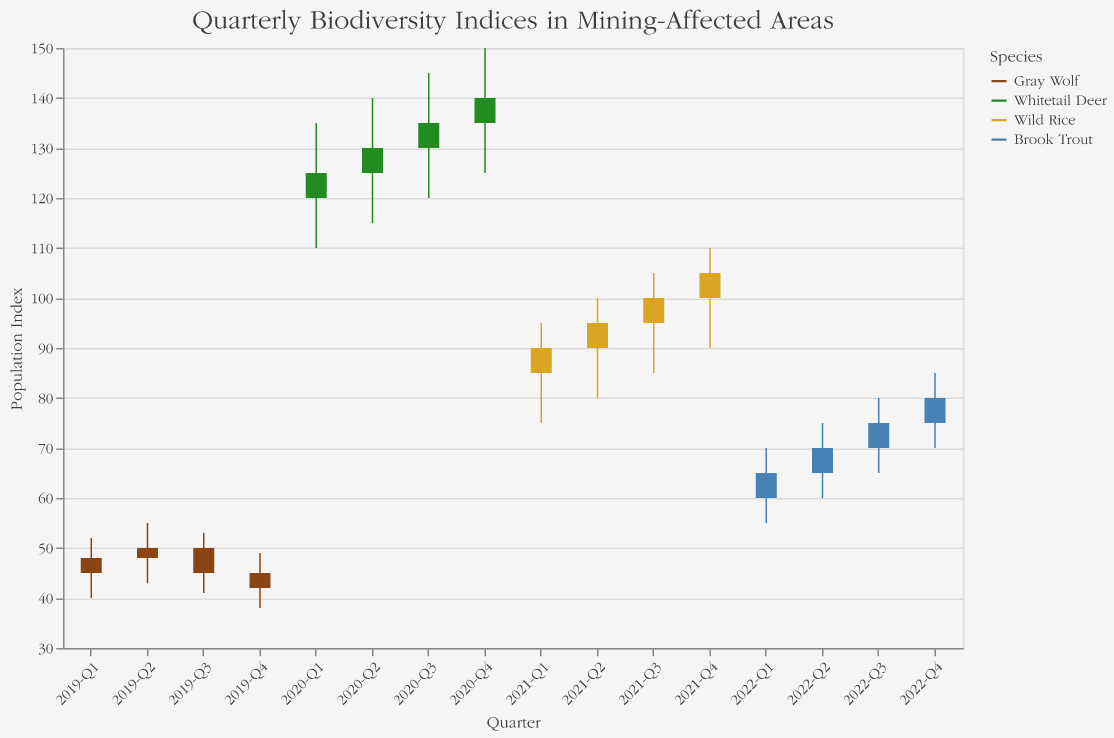What's the title of the figure? The title is located at the top of the figure and clearly states the focus of the data.
Answer: Quarterly Biodiversity Indices in Mining-Affected Areas How many different species are represented in the chart? The legend on the right side of the chart lists all the species included in the data.
Answer: Four Which quarter had the highest Close value for the Gray Wolf? Scan through the chart's Gray Wolf data points to identify the highest Close value.
Answer: 2019-Q2 What was the lowest recorded Low value for the Whitetail Deer, and during which quarter did it occur? Look at the Low values in the Whitetail Deer series to identify the lowest point and note the corresponding quarter.
Answer: 110 in 2020-Q1 Compare the opening index of Wild Rice in 2021-Q1 and 2021-Q2. Which one was higher? Check the Open values for 2021-Q1 and 2021-Q2 under the Wild Rice series and compare them.
Answer: 2021-Q2 What was the range (High minus Low) of the Brook Trout population index in 2022-Q1? Calculate the range by subtracting the Low value from the High value for Brook Trout in 2022-Q1.
Answer: 15 (70 - 55) Did the population index of the Gray Wolf generally increase or decrease over 2019? Look at the Open and Close values across the four quarters of 2019 for the Gray Wolf to determine the trend.
Answer: Decrease During which quarter did Whitetail Deer achieve its highest Close index? Identify the quarter with the highest Close value for Whitetail Deer by examining the data points.
Answer: 2020-Q4 Calculate the average Close index of Wild Rice for the year 2021. Sum the Close values for Wild Rice across all four quarters of 2021 and divide by 4 to find the average.
Answer: 97.5 ((90 + 95 + 100 + 105) / 4) Compare the Close index of Brook Trout in 2022-Q4 with the Open index of 2022-Q1. Which is higher? Look at the Close value for 2022-Q4 and the Open value for 2022-Q1 for Brook Trout and compare them.
Answer: 2022-Q4 